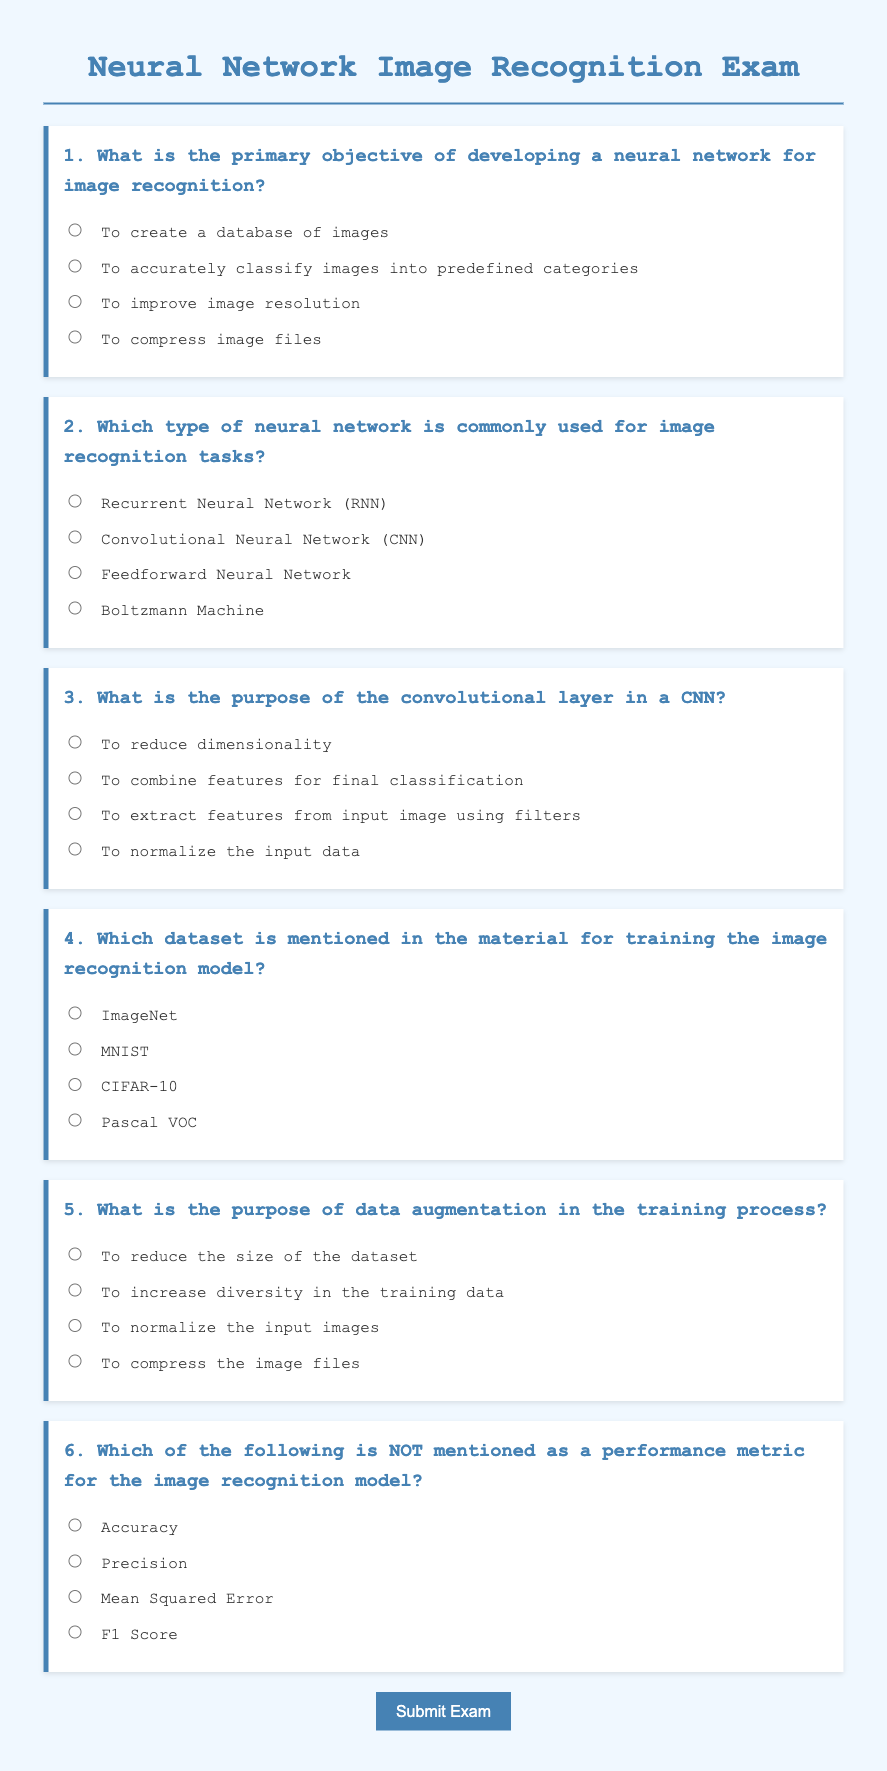What is the primary objective of developing a neural network for image recognition? The primary objective of developing a neural network for image recognition is to accurately classify images into predefined categories.
Answer: To accurately classify images into predefined categories Which type of neural network is commonly used for image recognition tasks? The document states that the type of neural network commonly used for image recognition tasks is the Convolutional Neural Network (CNN).
Answer: Convolutional Neural Network (CNN) What is the purpose of the convolutional layer in a CNN? The purpose of the convolutional layer in a CNN is to extract features from input image using filters.
Answer: To extract features from input image using filters Which dataset is mentioned in the material for training the image recognition model? The dataset mentioned for training the image recognition model is ImageNet.
Answer: ImageNet What is the purpose of data augmentation in the training process? The purpose of data augmentation in the training process is to increase diversity in the training data.
Answer: To increase diversity in the training data Which of the following is NOT mentioned as a performance metric for the image recognition model? The performance metric that is NOT mentioned in the document for the image recognition model is Mean Squared Error.
Answer: Mean Squared Error 